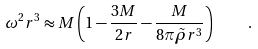<formula> <loc_0><loc_0><loc_500><loc_500>\omega ^ { 2 } r ^ { 3 } \approx M \left ( 1 - \frac { 3 M } { 2 r } - \frac { M } { 8 \pi \tilde { \rho } r ^ { 3 } } \right ) \quad .</formula> 